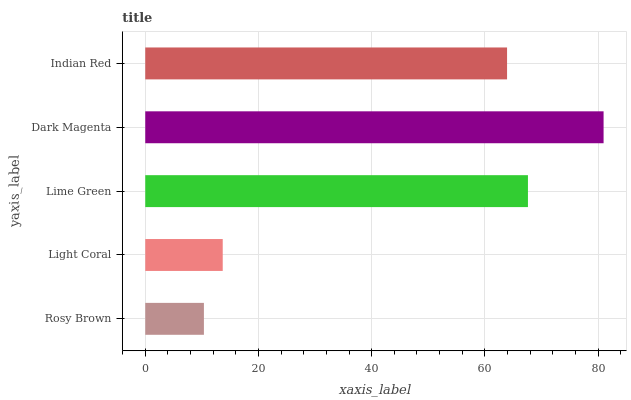Is Rosy Brown the minimum?
Answer yes or no. Yes. Is Dark Magenta the maximum?
Answer yes or no. Yes. Is Light Coral the minimum?
Answer yes or no. No. Is Light Coral the maximum?
Answer yes or no. No. Is Light Coral greater than Rosy Brown?
Answer yes or no. Yes. Is Rosy Brown less than Light Coral?
Answer yes or no. Yes. Is Rosy Brown greater than Light Coral?
Answer yes or no. No. Is Light Coral less than Rosy Brown?
Answer yes or no. No. Is Indian Red the high median?
Answer yes or no. Yes. Is Indian Red the low median?
Answer yes or no. Yes. Is Lime Green the high median?
Answer yes or no. No. Is Lime Green the low median?
Answer yes or no. No. 